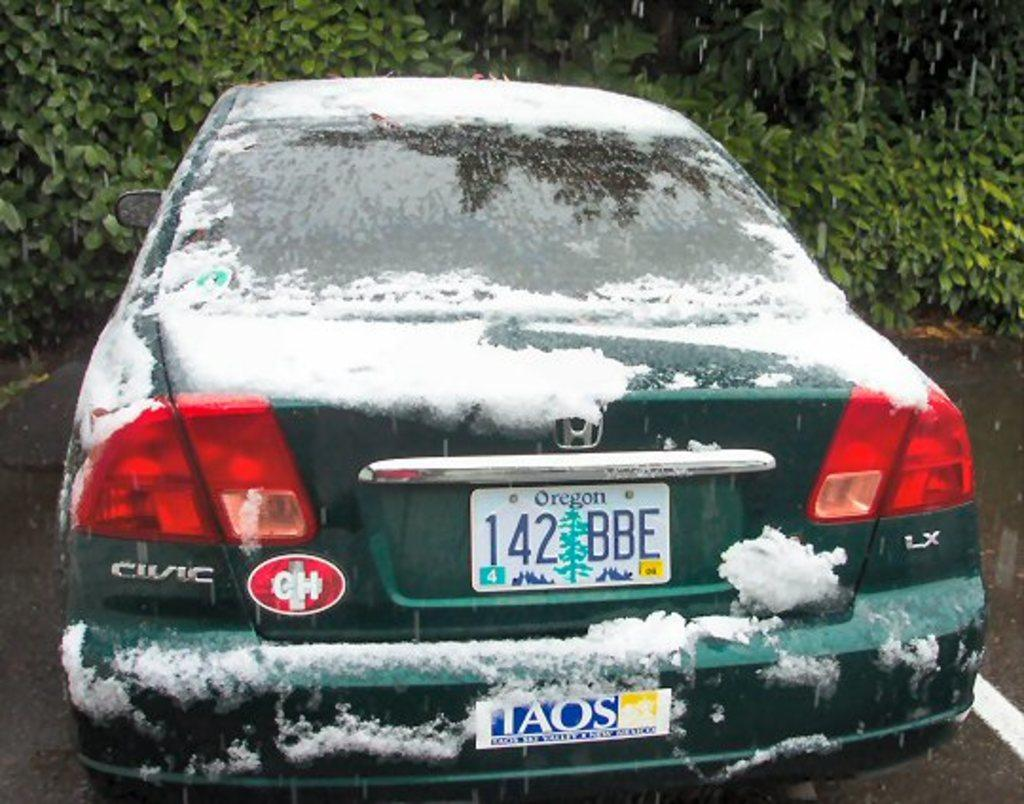Provide a one-sentence caption for the provided image. A green Honda Civic with an Oregon license plate has snow on it and is parked in front bushes. 